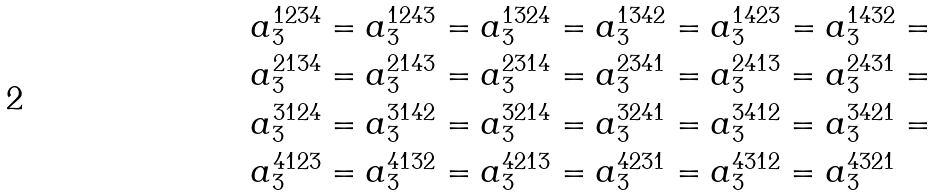Convert formula to latex. <formula><loc_0><loc_0><loc_500><loc_500>a _ { 3 } ^ { 1 2 3 4 } & = a _ { 3 } ^ { 1 2 4 3 } = a _ { 3 } ^ { 1 3 2 4 } = a _ { 3 } ^ { 1 3 4 2 } = a _ { 3 } ^ { 1 4 2 3 } = a _ { 3 } ^ { 1 4 3 2 } = \\ a _ { 3 } ^ { 2 1 3 4 } & = a _ { 3 } ^ { 2 1 4 3 } = a _ { 3 } ^ { 2 3 1 4 } = a _ { 3 } ^ { 2 3 4 1 } = a _ { 3 } ^ { 2 4 1 3 } = a _ { 3 } ^ { 2 4 3 1 } = \\ a _ { 3 } ^ { 3 1 2 4 } & = a _ { 3 } ^ { 3 1 4 2 } = a _ { 3 } ^ { 3 2 1 4 } = a _ { 3 } ^ { 3 2 4 1 } = a _ { 3 } ^ { 3 4 1 2 } = a _ { 3 } ^ { 3 4 2 1 } = \\ a _ { 3 } ^ { 4 1 2 3 } & = a _ { 3 } ^ { 4 1 3 2 } = a _ { 3 } ^ { 4 2 1 3 } = a _ { 3 } ^ { 4 2 3 1 } = a _ { 3 } ^ { 4 3 1 2 } = a _ { 3 } ^ { 4 3 2 1 }</formula> 